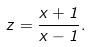<formula> <loc_0><loc_0><loc_500><loc_500>z = \frac { x + 1 } { x - 1 } .</formula> 